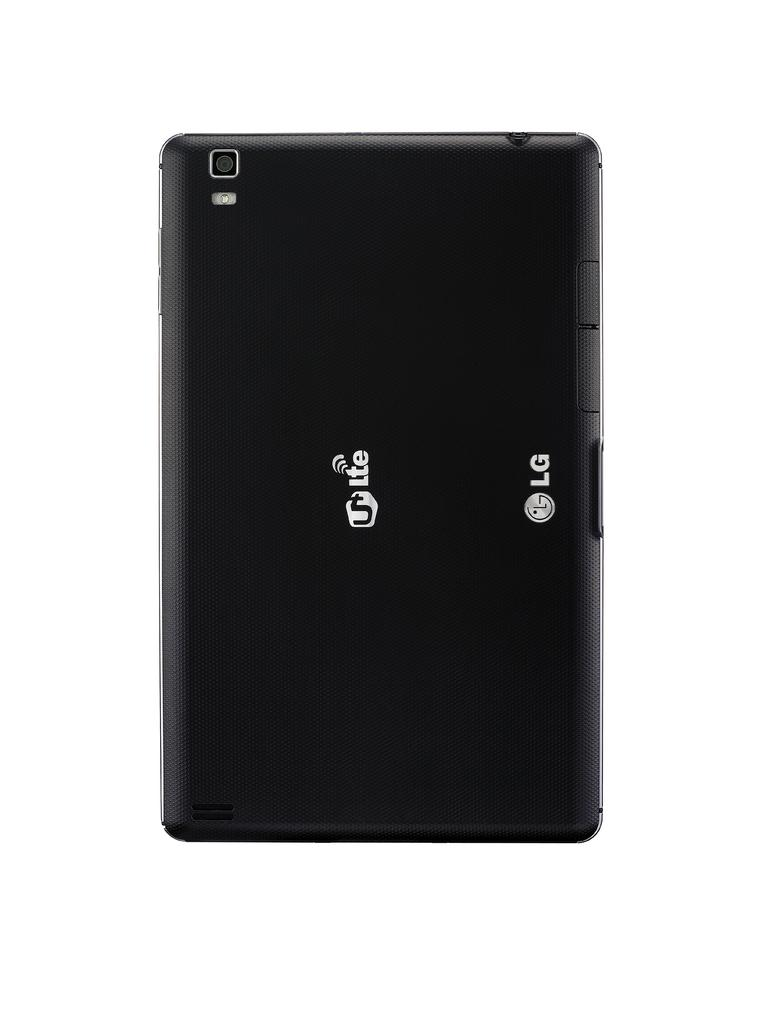<image>
Relay a brief, clear account of the picture shown. The back of a UT Lte tablet from the brand LG 